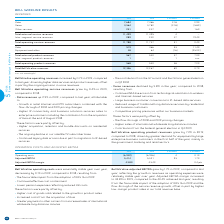From Bce's financial document, What are the favourable impact from the adoption of IFRS 16? The document shows two values: Continued effective cost containment and Lower pension expenses reflecting reduced DB costs. From the document: "• Lower pension expenses reflecting reduced DB costs • Continued effective cost containment..." Also, What is the % change in operating costs from 2018 to 2019? According to the financial document, 0.1%. The relevant text states: "Operating costs (6,942) (6,946) 4 0.1%..." Also, What is the % change in the adjusted EBITDA margin from 2018 to 2019? According to the financial document, 0.4 pts. The relevant text states: "Adjusted EBITDA margin 43.8% 43.4% 0.4 pts..." Also, can you calculate: What is the sum of the adjusted EBITDA in 2018 and 2019? Based on the calculation: 5,414+5,321, the result is 10735. This is based on the information: "Adjusted EBITDA 5,414 5,321 93 1.7% Adjusted EBITDA 5,414 5,321 93 1.7%..." The key data points involved are: 5,321, 5,414. Also, can you calculate: What is the sum of the operating costs in 2018 and 2019? Based on the calculation: -6,942+-6,946, the result is -13888. This is based on the information: "Operating costs (6,942) (6,946) 4 0.1% Operating costs (6,942) (6,946) 4 0.1%..." The key data points involved are: 6,942, 6,946. Also, can you calculate: What is the percentage of the 2019 adjusted EBITDA over the sum of the adjusted EBITDA in 2018 and 2019?  To answer this question, I need to perform calculations using the financial data. The calculation is: 5,414/(5,414+5,321), which equals 50.43 (percentage). This is based on the information: "Adjusted EBITDA 5,414 5,321 93 1.7% Adjusted EBITDA 5,414 5,321 93 1.7%..." The key data points involved are: 5,321, 5,414. 